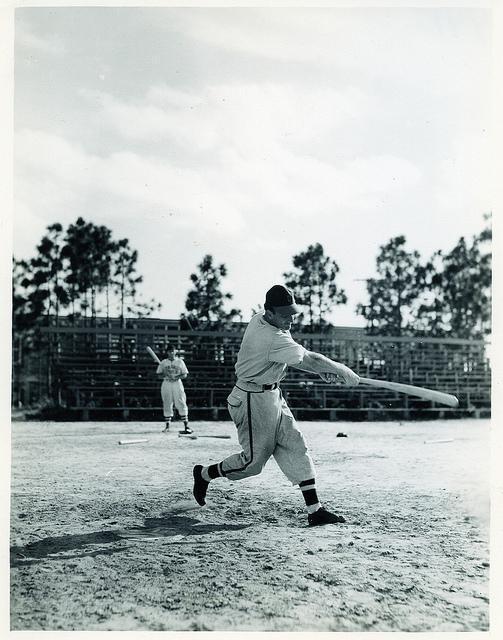How many airplanes are there flying in the photo?
Give a very brief answer. 0. 